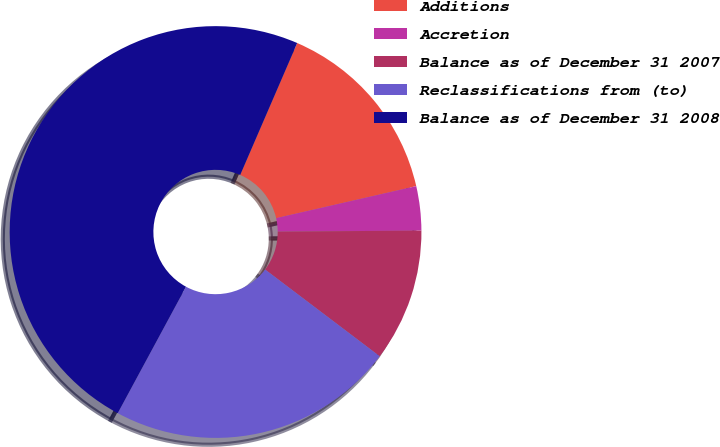Convert chart to OTSL. <chart><loc_0><loc_0><loc_500><loc_500><pie_chart><fcel>Additions<fcel>Accretion<fcel>Balance as of December 31 2007<fcel>Reclassifications from (to)<fcel>Balance as of December 31 2008<nl><fcel>14.93%<fcel>3.47%<fcel>10.42%<fcel>22.57%<fcel>48.61%<nl></chart> 